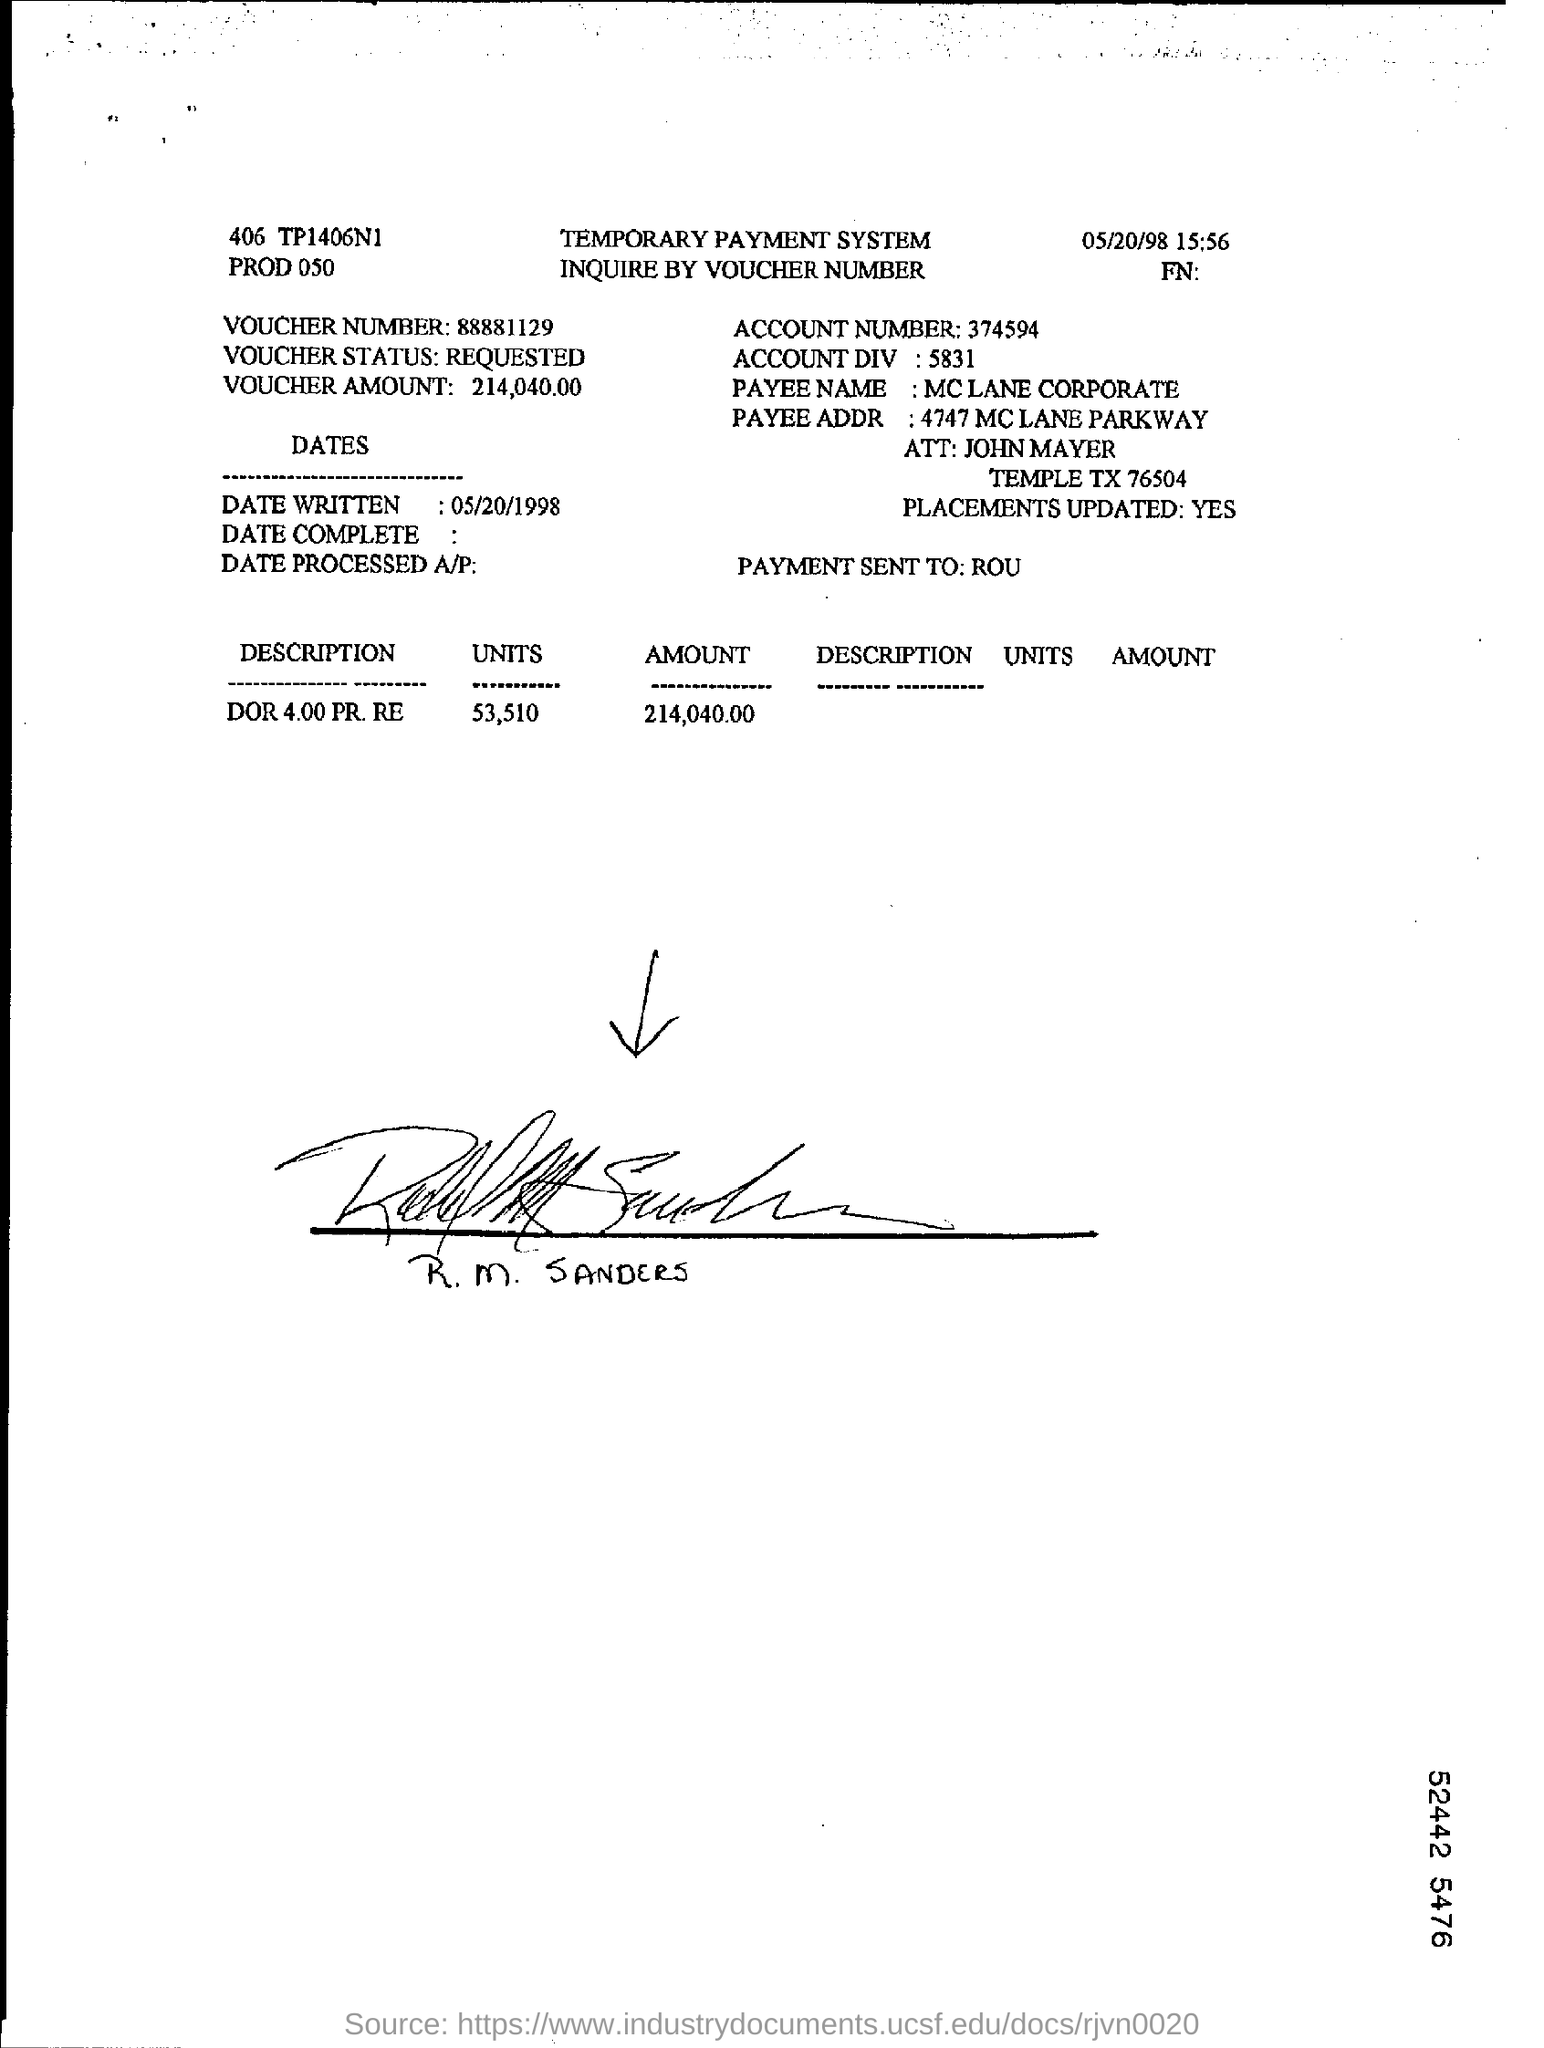Highlight a few significant elements in this photo. The payment has been sent to ROU. The amount is 214,040.00. The account number is 374594... The written date is 05/20/1998. The payee's name is MC LANE CORPORATE. 